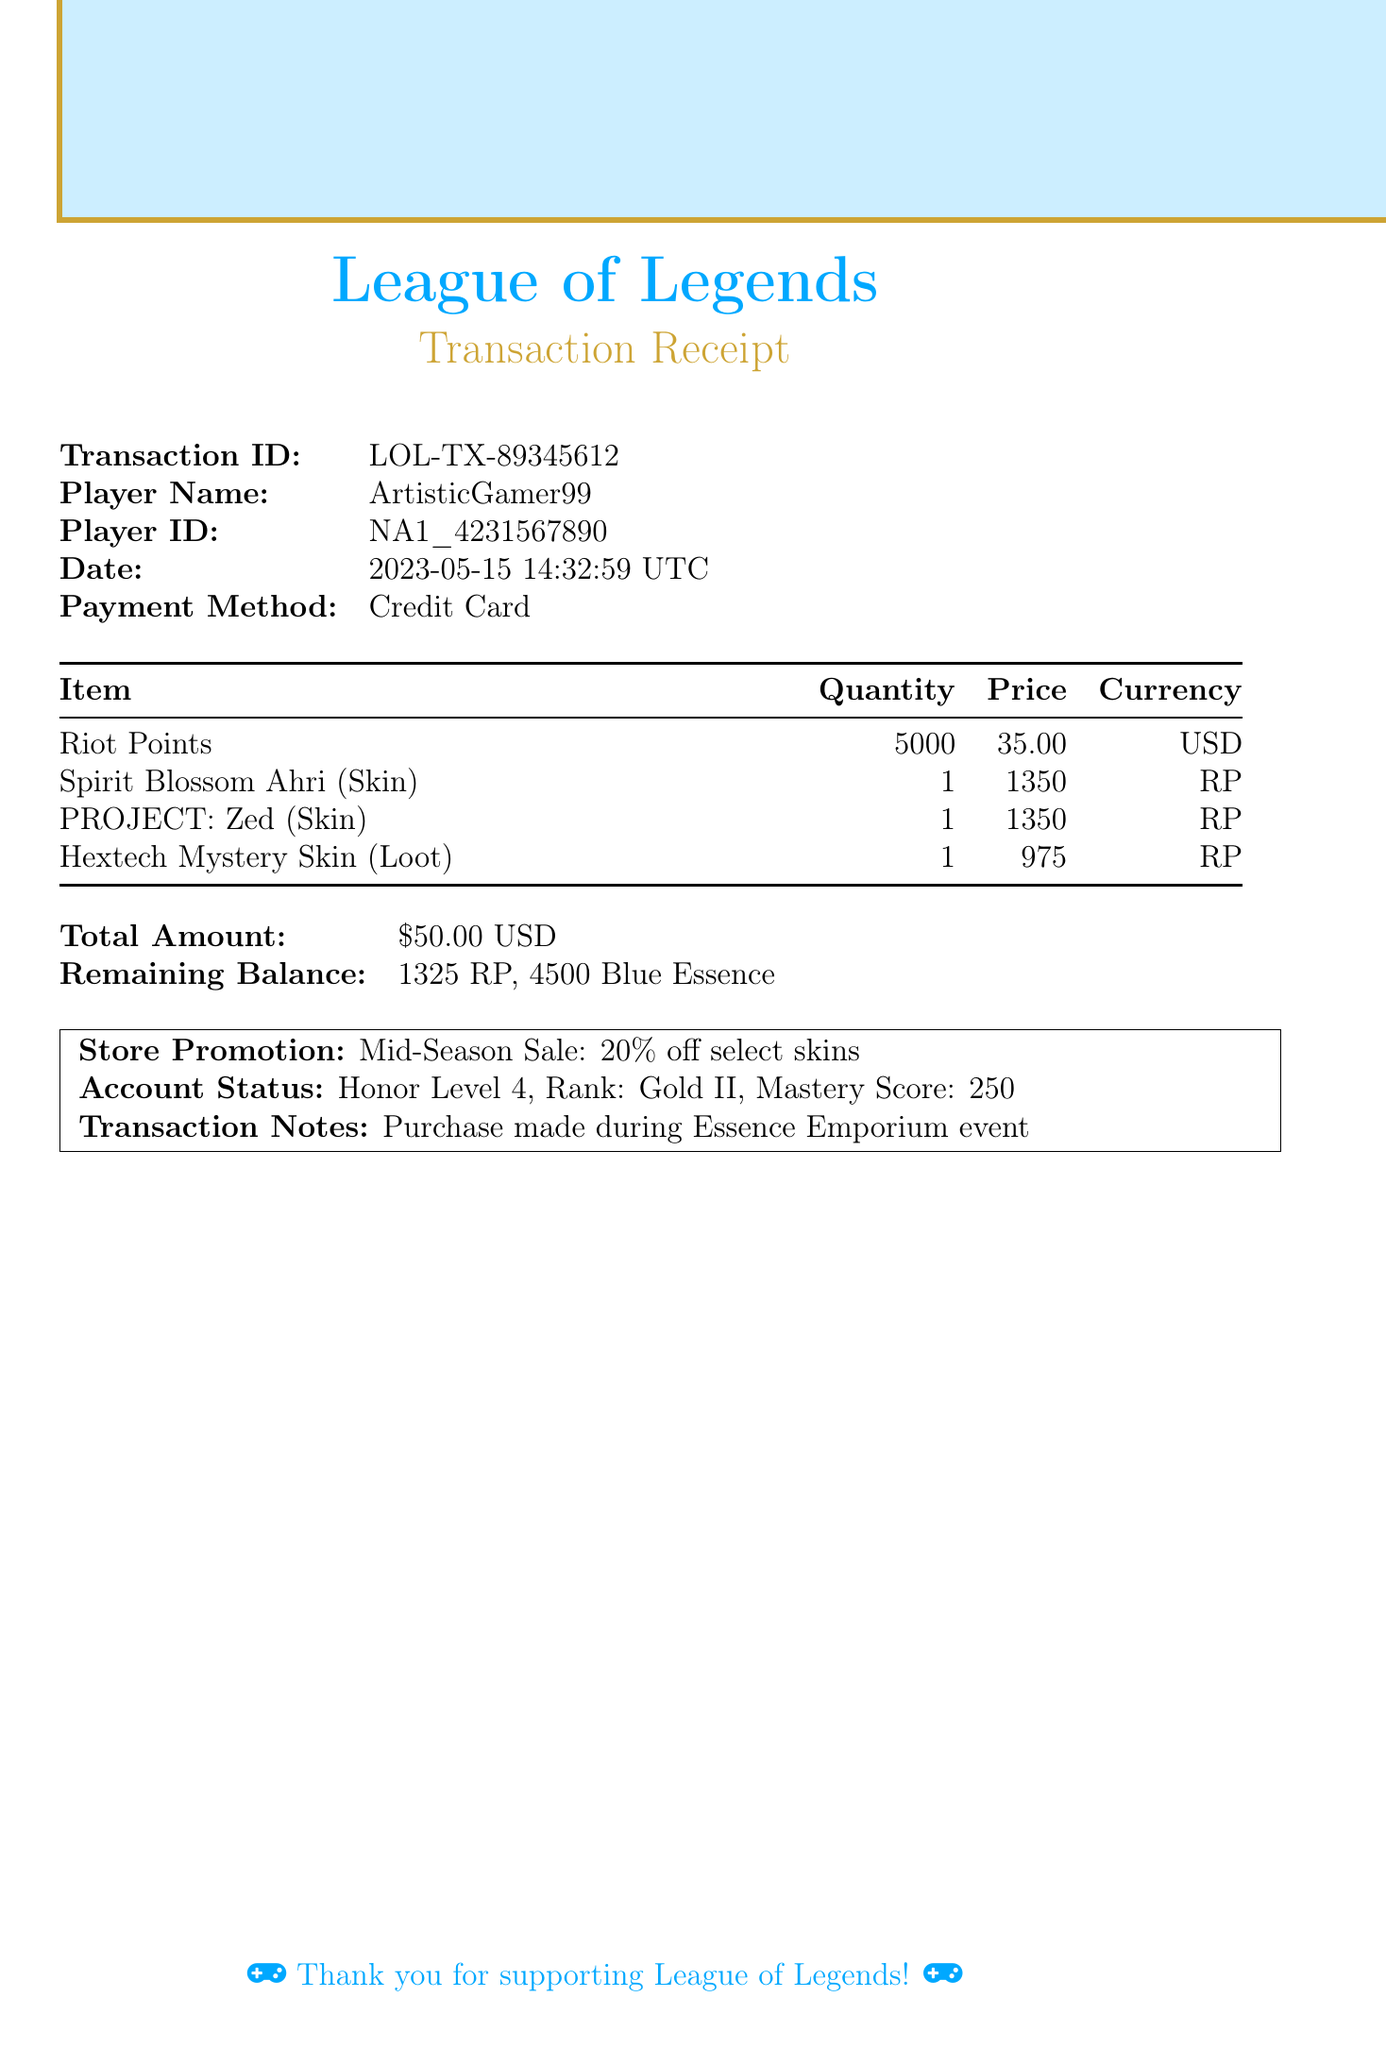What is the transaction ID? Each transaction has a unique identifier for tracking, which in this case is "LOL-TX-89345612".
Answer: LOL-TX-89345612 What is the total amount of the transaction? The total financial value of the purchase made by the player is indicated as $50.00.
Answer: $50.00 What item was purchased with the highest individual price? The highest priced item is determined by comparing the individual costs of the purchased items, which is the skins priced at 1350 RP.
Answer: Spirit Blossom Ahri, PROJECT: Zed What is the date of the transaction? The date of the transaction is specified to reflect when the purchase occurred, which is "2023-05-15T14:32:59Z".
Answer: 2023-05-15 How many Riot Points are remaining after the transaction? The remaining Riot Points indicate the balance after purchases were made, which is shown as 1325 RP.
Answer: 1325 RP What promotion was applicable during this transaction? The document outlines a promotion that may apply to the purchase, highlighted as "Mid-Season Sale: 20% off select skins".
Answer: Mid-Season Sale: 20% off select skins How many skins were purchased in total? By counting the individual skin entries listed in the items purchased, it can be noted that two skins were acquired.
Answer: 2 What payment method was used for this transaction? The method of payment indicates how the transaction was processed, which was done using a "Credit Card".
Answer: Credit Card What is the player's honor level? The document indicates the player's honor status, which is evaluated as an honor level of 4.
Answer: 4 What was the player's rank during this transaction? The rank indicates the player's competitive standing in the game, noted as "Gold II".
Answer: Gold II 